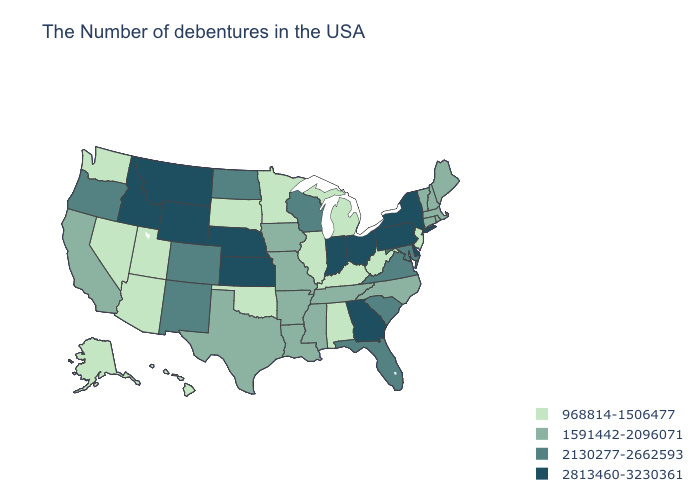Which states have the lowest value in the South?
Write a very short answer. West Virginia, Kentucky, Alabama, Oklahoma. Which states have the lowest value in the USA?
Be succinct. New Jersey, West Virginia, Michigan, Kentucky, Alabama, Illinois, Minnesota, Oklahoma, South Dakota, Utah, Arizona, Nevada, Washington, Alaska, Hawaii. Does the first symbol in the legend represent the smallest category?
Quick response, please. Yes. Name the states that have a value in the range 2130277-2662593?
Write a very short answer. Maryland, Virginia, South Carolina, Florida, Wisconsin, North Dakota, Colorado, New Mexico, Oregon. Does Washington have a lower value than South Dakota?
Write a very short answer. No. Name the states that have a value in the range 2813460-3230361?
Quick response, please. New York, Delaware, Pennsylvania, Ohio, Georgia, Indiana, Kansas, Nebraska, Wyoming, Montana, Idaho. What is the value of New Hampshire?
Be succinct. 1591442-2096071. Does Ohio have a lower value than Delaware?
Short answer required. No. What is the lowest value in states that border Oregon?
Concise answer only. 968814-1506477. What is the value of New Jersey?
Write a very short answer. 968814-1506477. How many symbols are there in the legend?
Concise answer only. 4. Among the states that border Massachusetts , which have the lowest value?
Write a very short answer. Rhode Island, New Hampshire, Vermont, Connecticut. Is the legend a continuous bar?
Quick response, please. No. Does Idaho have the highest value in the USA?
Write a very short answer. Yes. What is the highest value in the USA?
Keep it brief. 2813460-3230361. 